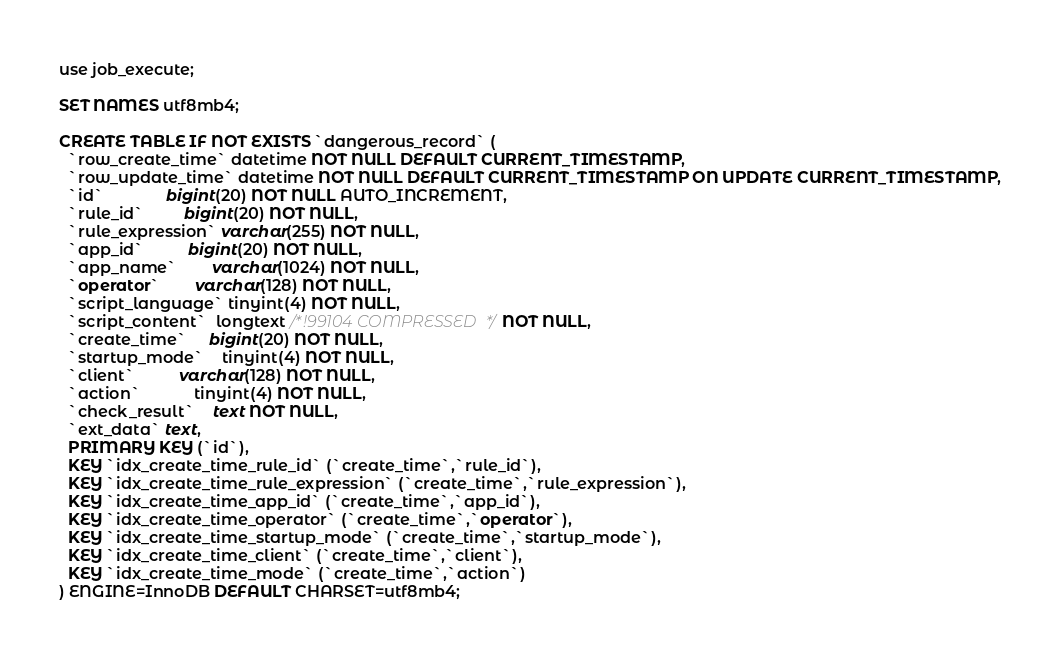<code> <loc_0><loc_0><loc_500><loc_500><_SQL_>use job_execute;

SET NAMES utf8mb4;

CREATE TABLE IF NOT EXISTS `dangerous_record` (
  `row_create_time` datetime NOT NULL DEFAULT CURRENT_TIMESTAMP,
  `row_update_time` datetime NOT NULL DEFAULT CURRENT_TIMESTAMP ON UPDATE CURRENT_TIMESTAMP,
  `id`              bigint(20) NOT NULL AUTO_INCREMENT,
  `rule_id`         bigint(20) NOT NULL,
  `rule_expression` varchar(255) NOT NULL,
  `app_id`          bigint(20) NOT NULL,
  `app_name`        varchar(1024) NOT NULL,
  `operator`        varchar(128) NOT NULL,
  `script_language` tinyint(4) NOT NULL,
  `script_content`  longtext /*!99104 COMPRESSED */ NOT NULL, 
  `create_time`     bigint(20) NOT NULL,
  `startup_mode`    tinyint(4) NOT NULL,
  `client`          varchar(128) NOT NULL,  
  `action`            tinyint(4) NOT NULL,
  `check_result`    text NOT NULL,
  `ext_data` text,
  PRIMARY KEY (`id`),
  KEY `idx_create_time_rule_id` (`create_time`,`rule_id`),
  KEY `idx_create_time_rule_expression` (`create_time`,`rule_expression`),
  KEY `idx_create_time_app_id` (`create_time`,`app_id`),
  KEY `idx_create_time_operator` (`create_time`,`operator`),
  KEY `idx_create_time_startup_mode` (`create_time`,`startup_mode`),
  KEY `idx_create_time_client` (`create_time`,`client`),
  KEY `idx_create_time_mode` (`create_time`,`action`)
) ENGINE=InnoDB DEFAULT CHARSET=utf8mb4;

</code> 